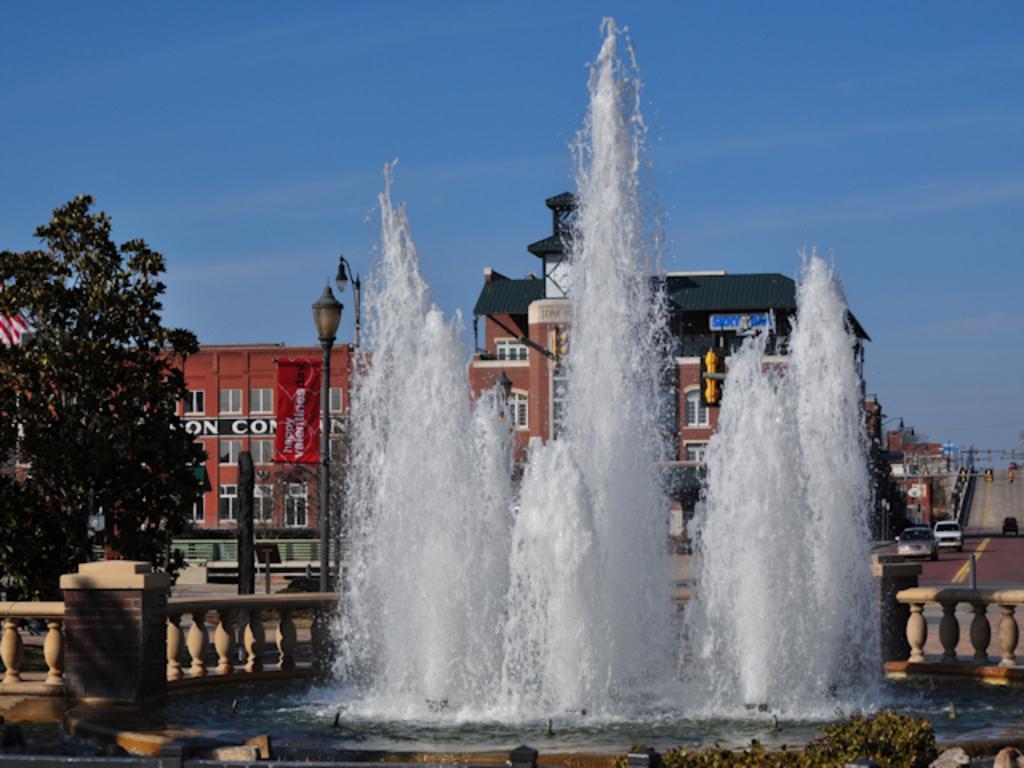Can you describe this image briefly? In the foreground of the image we can see a water fountain, a fence. In the background, we can see group of vehicles parked on the road, group of poles, building, tree and sky. 